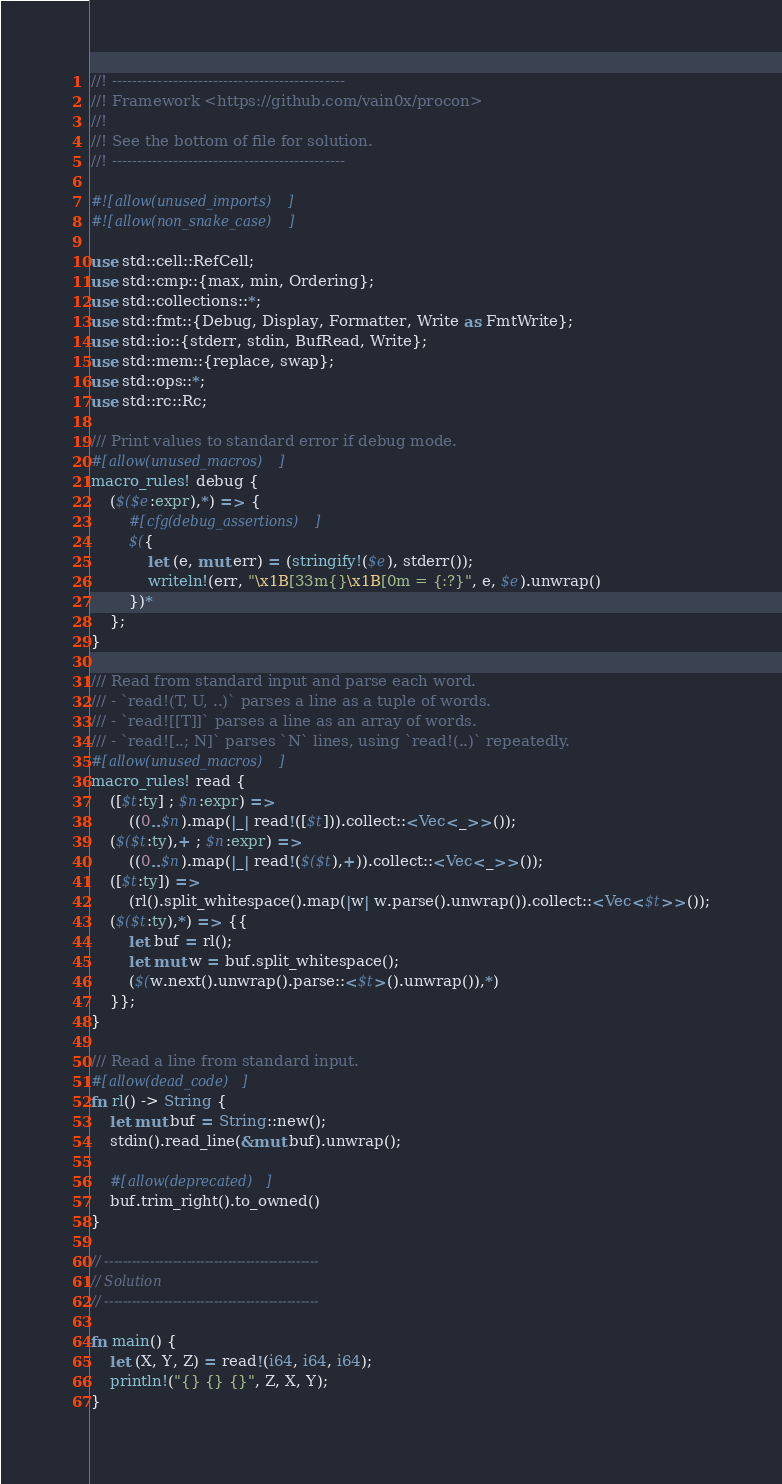<code> <loc_0><loc_0><loc_500><loc_500><_Rust_>//! ----------------------------------------------
//! Framework <https://github.com/vain0x/procon>
//!
//! See the bottom of file for solution.
//! ----------------------------------------------

#![allow(unused_imports)]
#![allow(non_snake_case)]

use std::cell::RefCell;
use std::cmp::{max, min, Ordering};
use std::collections::*;
use std::fmt::{Debug, Display, Formatter, Write as FmtWrite};
use std::io::{stderr, stdin, BufRead, Write};
use std::mem::{replace, swap};
use std::ops::*;
use std::rc::Rc;

/// Print values to standard error if debug mode.
#[allow(unused_macros)]
macro_rules! debug {
    ($($e:expr),*) => {
        #[cfg(debug_assertions)]
        $({
            let (e, mut err) = (stringify!($e), stderr());
            writeln!(err, "\x1B[33m{}\x1B[0m = {:?}", e, $e).unwrap()
        })*
    };
}

/// Read from standard input and parse each word.
/// - `read!(T, U, ..)` parses a line as a tuple of words.
/// - `read![[T]]` parses a line as an array of words.
/// - `read![..; N]` parses `N` lines, using `read!(..)` repeatedly.
#[allow(unused_macros)]
macro_rules! read {
    ([$t:ty] ; $n:expr) =>
        ((0..$n).map(|_| read!([$t])).collect::<Vec<_>>());
    ($($t:ty),+ ; $n:expr) =>
        ((0..$n).map(|_| read!($($t),+)).collect::<Vec<_>>());
    ([$t:ty]) =>
        (rl().split_whitespace().map(|w| w.parse().unwrap()).collect::<Vec<$t>>());
    ($($t:ty),*) => {{
        let buf = rl();
        let mut w = buf.split_whitespace();
        ($(w.next().unwrap().parse::<$t>().unwrap()),*)
    }};
}

/// Read a line from standard input.
#[allow(dead_code)]
fn rl() -> String {
    let mut buf = String::new();
    stdin().read_line(&mut buf).unwrap();

    #[allow(deprecated)]
    buf.trim_right().to_owned()
}

// -----------------------------------------------
// Solution
// -----------------------------------------------

fn main() {
    let (X, Y, Z) = read!(i64, i64, i64);
    println!("{} {} {}", Z, X, Y);
}
</code> 